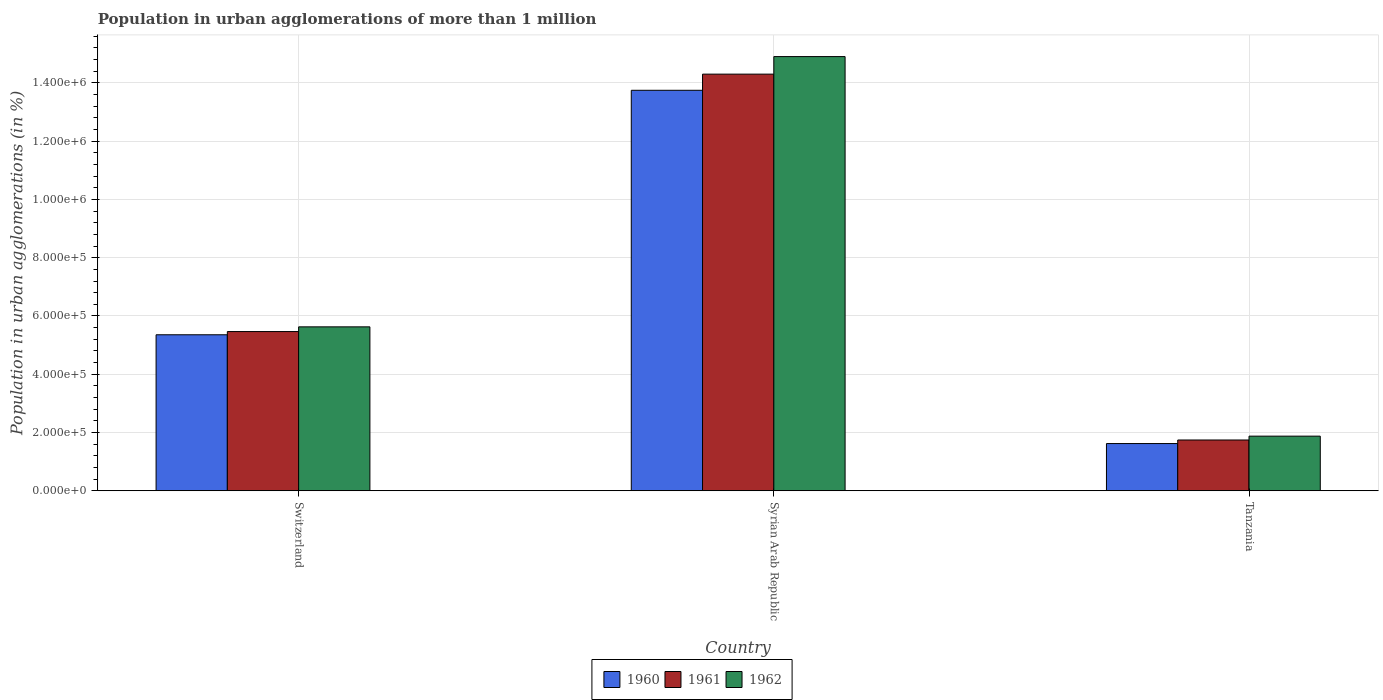How many different coloured bars are there?
Make the answer very short. 3. What is the label of the 1st group of bars from the left?
Make the answer very short. Switzerland. In how many cases, is the number of bars for a given country not equal to the number of legend labels?
Your response must be concise. 0. What is the population in urban agglomerations in 1961 in Switzerland?
Provide a succinct answer. 5.46e+05. Across all countries, what is the maximum population in urban agglomerations in 1962?
Keep it short and to the point. 1.49e+06. Across all countries, what is the minimum population in urban agglomerations in 1961?
Provide a short and direct response. 1.74e+05. In which country was the population in urban agglomerations in 1960 maximum?
Offer a very short reply. Syrian Arab Republic. In which country was the population in urban agglomerations in 1962 minimum?
Your answer should be compact. Tanzania. What is the total population in urban agglomerations in 1962 in the graph?
Your answer should be very brief. 2.24e+06. What is the difference between the population in urban agglomerations in 1961 in Syrian Arab Republic and that in Tanzania?
Offer a terse response. 1.26e+06. What is the difference between the population in urban agglomerations in 1961 in Syrian Arab Republic and the population in urban agglomerations in 1962 in Tanzania?
Your answer should be compact. 1.24e+06. What is the average population in urban agglomerations in 1961 per country?
Provide a succinct answer. 7.17e+05. What is the difference between the population in urban agglomerations of/in 1960 and population in urban agglomerations of/in 1961 in Tanzania?
Ensure brevity in your answer.  -1.22e+04. In how many countries, is the population in urban agglomerations in 1960 greater than 1440000 %?
Provide a succinct answer. 0. What is the ratio of the population in urban agglomerations in 1960 in Switzerland to that in Tanzania?
Your answer should be very brief. 3.3. Is the difference between the population in urban agglomerations in 1960 in Switzerland and Tanzania greater than the difference between the population in urban agglomerations in 1961 in Switzerland and Tanzania?
Give a very brief answer. Yes. What is the difference between the highest and the second highest population in urban agglomerations in 1960?
Keep it short and to the point. 1.21e+06. What is the difference between the highest and the lowest population in urban agglomerations in 1962?
Provide a short and direct response. 1.30e+06. In how many countries, is the population in urban agglomerations in 1962 greater than the average population in urban agglomerations in 1962 taken over all countries?
Keep it short and to the point. 1. Is the sum of the population in urban agglomerations in 1960 in Switzerland and Syrian Arab Republic greater than the maximum population in urban agglomerations in 1961 across all countries?
Make the answer very short. Yes. What does the 1st bar from the left in Syrian Arab Republic represents?
Keep it short and to the point. 1960. What does the 3rd bar from the right in Tanzania represents?
Provide a succinct answer. 1960. How many bars are there?
Offer a very short reply. 9. How many countries are there in the graph?
Provide a short and direct response. 3. What is the difference between two consecutive major ticks on the Y-axis?
Give a very brief answer. 2.00e+05. Does the graph contain any zero values?
Ensure brevity in your answer.  No. Does the graph contain grids?
Offer a very short reply. Yes. How many legend labels are there?
Give a very brief answer. 3. How are the legend labels stacked?
Your answer should be compact. Horizontal. What is the title of the graph?
Keep it short and to the point. Population in urban agglomerations of more than 1 million. What is the label or title of the X-axis?
Provide a short and direct response. Country. What is the label or title of the Y-axis?
Offer a very short reply. Population in urban agglomerations (in %). What is the Population in urban agglomerations (in %) of 1960 in Switzerland?
Offer a terse response. 5.35e+05. What is the Population in urban agglomerations (in %) in 1961 in Switzerland?
Make the answer very short. 5.46e+05. What is the Population in urban agglomerations (in %) in 1962 in Switzerland?
Your answer should be very brief. 5.63e+05. What is the Population in urban agglomerations (in %) of 1960 in Syrian Arab Republic?
Make the answer very short. 1.37e+06. What is the Population in urban agglomerations (in %) in 1961 in Syrian Arab Republic?
Your answer should be compact. 1.43e+06. What is the Population in urban agglomerations (in %) of 1962 in Syrian Arab Republic?
Make the answer very short. 1.49e+06. What is the Population in urban agglomerations (in %) in 1960 in Tanzania?
Provide a short and direct response. 1.62e+05. What is the Population in urban agglomerations (in %) of 1961 in Tanzania?
Your response must be concise. 1.74e+05. What is the Population in urban agglomerations (in %) in 1962 in Tanzania?
Provide a short and direct response. 1.88e+05. Across all countries, what is the maximum Population in urban agglomerations (in %) in 1960?
Your response must be concise. 1.37e+06. Across all countries, what is the maximum Population in urban agglomerations (in %) of 1961?
Your response must be concise. 1.43e+06. Across all countries, what is the maximum Population in urban agglomerations (in %) of 1962?
Your answer should be very brief. 1.49e+06. Across all countries, what is the minimum Population in urban agglomerations (in %) in 1960?
Offer a terse response. 1.62e+05. Across all countries, what is the minimum Population in urban agglomerations (in %) in 1961?
Offer a very short reply. 1.74e+05. Across all countries, what is the minimum Population in urban agglomerations (in %) in 1962?
Ensure brevity in your answer.  1.88e+05. What is the total Population in urban agglomerations (in %) of 1960 in the graph?
Your answer should be compact. 2.07e+06. What is the total Population in urban agglomerations (in %) in 1961 in the graph?
Keep it short and to the point. 2.15e+06. What is the total Population in urban agglomerations (in %) of 1962 in the graph?
Offer a very short reply. 2.24e+06. What is the difference between the Population in urban agglomerations (in %) in 1960 in Switzerland and that in Syrian Arab Republic?
Give a very brief answer. -8.39e+05. What is the difference between the Population in urban agglomerations (in %) of 1961 in Switzerland and that in Syrian Arab Republic?
Your answer should be very brief. -8.83e+05. What is the difference between the Population in urban agglomerations (in %) in 1962 in Switzerland and that in Syrian Arab Republic?
Make the answer very short. -9.28e+05. What is the difference between the Population in urban agglomerations (in %) of 1960 in Switzerland and that in Tanzania?
Provide a short and direct response. 3.73e+05. What is the difference between the Population in urban agglomerations (in %) in 1961 in Switzerland and that in Tanzania?
Offer a terse response. 3.72e+05. What is the difference between the Population in urban agglomerations (in %) in 1962 in Switzerland and that in Tanzania?
Offer a terse response. 3.75e+05. What is the difference between the Population in urban agglomerations (in %) of 1960 in Syrian Arab Republic and that in Tanzania?
Your response must be concise. 1.21e+06. What is the difference between the Population in urban agglomerations (in %) in 1961 in Syrian Arab Republic and that in Tanzania?
Your answer should be compact. 1.26e+06. What is the difference between the Population in urban agglomerations (in %) in 1962 in Syrian Arab Republic and that in Tanzania?
Keep it short and to the point. 1.30e+06. What is the difference between the Population in urban agglomerations (in %) in 1960 in Switzerland and the Population in urban agglomerations (in %) in 1961 in Syrian Arab Republic?
Give a very brief answer. -8.94e+05. What is the difference between the Population in urban agglomerations (in %) in 1960 in Switzerland and the Population in urban agglomerations (in %) in 1962 in Syrian Arab Republic?
Your answer should be very brief. -9.55e+05. What is the difference between the Population in urban agglomerations (in %) in 1961 in Switzerland and the Population in urban agglomerations (in %) in 1962 in Syrian Arab Republic?
Offer a very short reply. -9.44e+05. What is the difference between the Population in urban agglomerations (in %) of 1960 in Switzerland and the Population in urban agglomerations (in %) of 1961 in Tanzania?
Make the answer very short. 3.61e+05. What is the difference between the Population in urban agglomerations (in %) of 1960 in Switzerland and the Population in urban agglomerations (in %) of 1962 in Tanzania?
Your response must be concise. 3.48e+05. What is the difference between the Population in urban agglomerations (in %) of 1961 in Switzerland and the Population in urban agglomerations (in %) of 1962 in Tanzania?
Provide a short and direct response. 3.59e+05. What is the difference between the Population in urban agglomerations (in %) of 1960 in Syrian Arab Republic and the Population in urban agglomerations (in %) of 1961 in Tanzania?
Give a very brief answer. 1.20e+06. What is the difference between the Population in urban agglomerations (in %) in 1960 in Syrian Arab Republic and the Population in urban agglomerations (in %) in 1962 in Tanzania?
Make the answer very short. 1.19e+06. What is the difference between the Population in urban agglomerations (in %) in 1961 in Syrian Arab Republic and the Population in urban agglomerations (in %) in 1962 in Tanzania?
Give a very brief answer. 1.24e+06. What is the average Population in urban agglomerations (in %) of 1960 per country?
Make the answer very short. 6.91e+05. What is the average Population in urban agglomerations (in %) in 1961 per country?
Provide a succinct answer. 7.17e+05. What is the average Population in urban agglomerations (in %) of 1962 per country?
Offer a terse response. 7.47e+05. What is the difference between the Population in urban agglomerations (in %) in 1960 and Population in urban agglomerations (in %) in 1961 in Switzerland?
Offer a terse response. -1.10e+04. What is the difference between the Population in urban agglomerations (in %) of 1960 and Population in urban agglomerations (in %) of 1962 in Switzerland?
Make the answer very short. -2.72e+04. What is the difference between the Population in urban agglomerations (in %) of 1961 and Population in urban agglomerations (in %) of 1962 in Switzerland?
Offer a very short reply. -1.62e+04. What is the difference between the Population in urban agglomerations (in %) in 1960 and Population in urban agglomerations (in %) in 1961 in Syrian Arab Republic?
Your response must be concise. -5.54e+04. What is the difference between the Population in urban agglomerations (in %) in 1960 and Population in urban agglomerations (in %) in 1962 in Syrian Arab Republic?
Ensure brevity in your answer.  -1.16e+05. What is the difference between the Population in urban agglomerations (in %) of 1961 and Population in urban agglomerations (in %) of 1962 in Syrian Arab Republic?
Your response must be concise. -6.03e+04. What is the difference between the Population in urban agglomerations (in %) of 1960 and Population in urban agglomerations (in %) of 1961 in Tanzania?
Your answer should be very brief. -1.22e+04. What is the difference between the Population in urban agglomerations (in %) in 1960 and Population in urban agglomerations (in %) in 1962 in Tanzania?
Your answer should be compact. -2.54e+04. What is the difference between the Population in urban agglomerations (in %) in 1961 and Population in urban agglomerations (in %) in 1962 in Tanzania?
Make the answer very short. -1.32e+04. What is the ratio of the Population in urban agglomerations (in %) in 1960 in Switzerland to that in Syrian Arab Republic?
Keep it short and to the point. 0.39. What is the ratio of the Population in urban agglomerations (in %) in 1961 in Switzerland to that in Syrian Arab Republic?
Offer a terse response. 0.38. What is the ratio of the Population in urban agglomerations (in %) in 1962 in Switzerland to that in Syrian Arab Republic?
Your response must be concise. 0.38. What is the ratio of the Population in urban agglomerations (in %) of 1960 in Switzerland to that in Tanzania?
Your answer should be compact. 3.3. What is the ratio of the Population in urban agglomerations (in %) of 1961 in Switzerland to that in Tanzania?
Offer a terse response. 3.13. What is the ratio of the Population in urban agglomerations (in %) of 1962 in Switzerland to that in Tanzania?
Make the answer very short. 3. What is the ratio of the Population in urban agglomerations (in %) in 1960 in Syrian Arab Republic to that in Tanzania?
Your answer should be very brief. 8.48. What is the ratio of the Population in urban agglomerations (in %) in 1961 in Syrian Arab Republic to that in Tanzania?
Your answer should be very brief. 8.2. What is the ratio of the Population in urban agglomerations (in %) of 1962 in Syrian Arab Republic to that in Tanzania?
Make the answer very short. 7.95. What is the difference between the highest and the second highest Population in urban agglomerations (in %) in 1960?
Give a very brief answer. 8.39e+05. What is the difference between the highest and the second highest Population in urban agglomerations (in %) in 1961?
Provide a succinct answer. 8.83e+05. What is the difference between the highest and the second highest Population in urban agglomerations (in %) of 1962?
Offer a very short reply. 9.28e+05. What is the difference between the highest and the lowest Population in urban agglomerations (in %) of 1960?
Offer a terse response. 1.21e+06. What is the difference between the highest and the lowest Population in urban agglomerations (in %) of 1961?
Your response must be concise. 1.26e+06. What is the difference between the highest and the lowest Population in urban agglomerations (in %) in 1962?
Your response must be concise. 1.30e+06. 